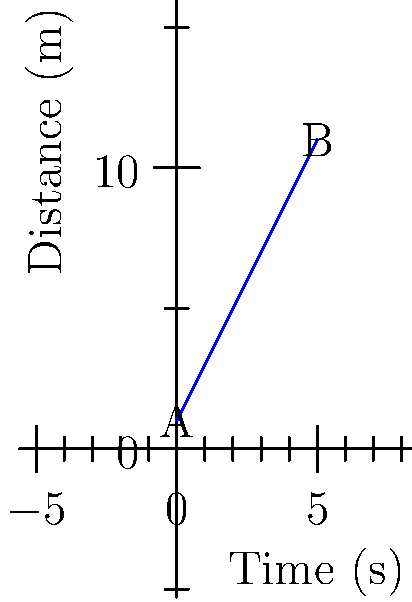As an instructor teaching industry-specific skills, you're demonstrating how to analyze distance-time graphs. The graph above shows the motion of an object over 5 seconds. Calculate the velocity of the object between points A and B. To calculate the velocity of the object, we need to follow these steps:

1. Identify the change in distance (displacement):
   - Initial position (A): $y_1 = 1$ m
   - Final position (B): $y_2 = 11$ m
   - Displacement: $\Delta y = y_2 - y_1 = 11 - 1 = 10$ m

2. Identify the change in time:
   - Initial time: $t_1 = 0$ s
   - Final time: $t_2 = 5$ s
   - Time interval: $\Delta t = t_2 - t_1 = 5 - 0 = 5$ s

3. Calculate the velocity using the formula:
   $$v = \frac{\Delta y}{\Delta t}$$

4. Substitute the values:
   $$v = \frac{10 \text{ m}}{5 \text{ s}} = 2 \text{ m/s}$$

Therefore, the velocity of the object between points A and B is 2 m/s.

Note: The straight line on the distance-time graph indicates constant velocity, which means the object is moving at a steady speed throughout the 5-second interval.
Answer: 2 m/s 